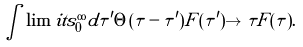<formula> <loc_0><loc_0><loc_500><loc_500>\int \lim i t s _ { 0 } ^ { \infty } d \tau ^ { \prime } \Theta ( \tau - \tau ^ { \prime } ) F ( \tau ^ { \prime } ) \to \tau F ( \tau ) .</formula> 